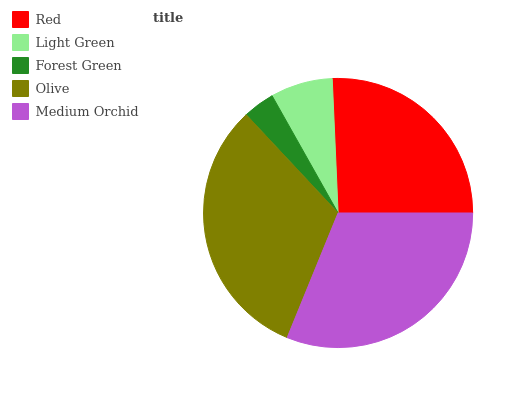Is Forest Green the minimum?
Answer yes or no. Yes. Is Olive the maximum?
Answer yes or no. Yes. Is Light Green the minimum?
Answer yes or no. No. Is Light Green the maximum?
Answer yes or no. No. Is Red greater than Light Green?
Answer yes or no. Yes. Is Light Green less than Red?
Answer yes or no. Yes. Is Light Green greater than Red?
Answer yes or no. No. Is Red less than Light Green?
Answer yes or no. No. Is Red the high median?
Answer yes or no. Yes. Is Red the low median?
Answer yes or no. Yes. Is Light Green the high median?
Answer yes or no. No. Is Forest Green the low median?
Answer yes or no. No. 